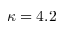<formula> <loc_0><loc_0><loc_500><loc_500>\kappa = 4 . 2</formula> 